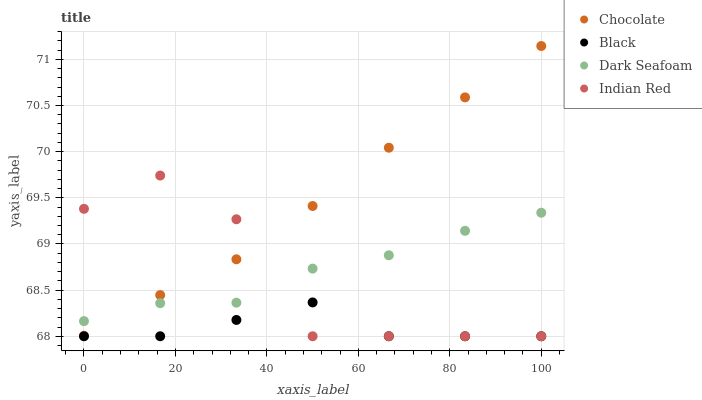Does Black have the minimum area under the curve?
Answer yes or no. Yes. Does Chocolate have the maximum area under the curve?
Answer yes or no. Yes. Does Indian Red have the minimum area under the curve?
Answer yes or no. No. Does Indian Red have the maximum area under the curve?
Answer yes or no. No. Is Chocolate the smoothest?
Answer yes or no. Yes. Is Indian Red the roughest?
Answer yes or no. Yes. Is Black the smoothest?
Answer yes or no. No. Is Black the roughest?
Answer yes or no. No. Does Black have the lowest value?
Answer yes or no. Yes. Does Chocolate have the lowest value?
Answer yes or no. No. Does Chocolate have the highest value?
Answer yes or no. Yes. Does Indian Red have the highest value?
Answer yes or no. No. Is Black less than Dark Seafoam?
Answer yes or no. Yes. Is Chocolate greater than Black?
Answer yes or no. Yes. Does Indian Red intersect Black?
Answer yes or no. Yes. Is Indian Red less than Black?
Answer yes or no. No. Is Indian Red greater than Black?
Answer yes or no. No. Does Black intersect Dark Seafoam?
Answer yes or no. No. 